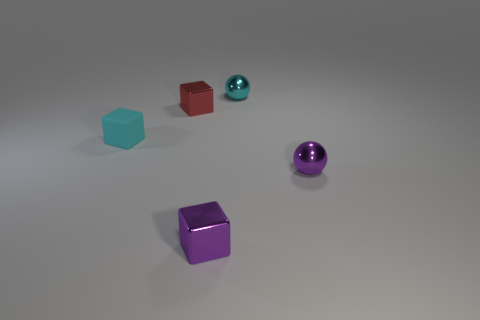Are there more shiny spheres behind the cyan rubber cube than cyan rubber objects that are behind the tiny red shiny cube?
Make the answer very short. Yes. There is a purple cube to the right of the red cube; is it the same size as the shiny ball in front of the tiny cyan metallic object?
Offer a terse response. Yes. The cyan rubber object has what shape?
Provide a succinct answer. Cube. What size is the shiny object that is the same color as the matte block?
Ensure brevity in your answer.  Small. There is another small sphere that is the same material as the cyan ball; what is its color?
Provide a short and direct response. Purple. Is the material of the small red thing the same as the tiny cube that is to the left of the small red block?
Your answer should be very brief. No. The tiny rubber thing has what color?
Your answer should be very brief. Cyan. What size is the red object that is the same material as the tiny purple block?
Give a very brief answer. Small. What number of blocks are to the left of the purple shiny object to the right of the small metallic block to the right of the red object?
Offer a terse response. 3. Is the color of the small rubber block the same as the metallic thing on the left side of the purple metallic cube?
Keep it short and to the point. No. 